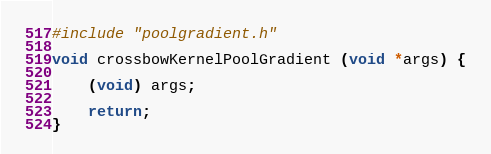<code> <loc_0><loc_0><loc_500><loc_500><_Cuda_>#include "poolgradient.h"

void crossbowKernelPoolGradient (void *args) {

	(void) args;

	return;
}

</code> 